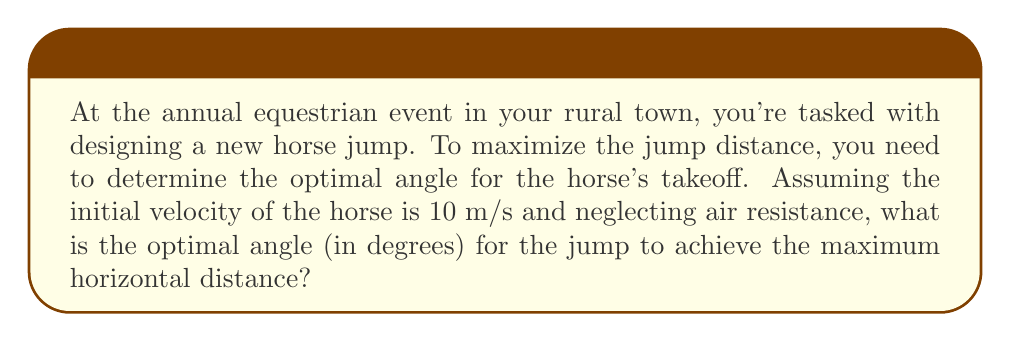What is the answer to this math problem? To solve this problem, we'll use the principles of projectile motion in calculus. The optimal angle for maximum distance in projectile motion is always 45°, but let's derive this mathematically:

1. The horizontal distance (d) traveled by a projectile is given by:
   $$d = v_0 \cos(\theta) \cdot t$$
   where $v_0$ is the initial velocity, $\theta$ is the launch angle, and $t$ is the time of flight.

2. The time of flight is determined by the vertical motion:
   $$t = \frac{2v_0 \sin(\theta)}{g}$$
   where $g$ is the acceleration due to gravity (9.8 m/s²).

3. Substituting the time into the distance equation:
   $$d = v_0 \cos(\theta) \cdot \frac{2v_0 \sin(\theta)}{g} = \frac{2v_0^2}{g} \sin(\theta)\cos(\theta)$$

4. Using the trigonometric identity $\sin(2\theta) = 2\sin(\theta)\cos(\theta)$, we get:
   $$d = \frac{v_0^2}{g} \sin(2\theta)$$

5. To find the maximum distance, we differentiate with respect to $\theta$ and set it to zero:
   $$\frac{dd}{d\theta} = \frac{v_0^2}{g} \cdot 2\cos(2\theta) = 0$$

6. Solving this equation:
   $$2\cos(2\theta) = 0$$
   $$\cos(2\theta) = 0$$
   $$2\theta = 90°$$
   $$\theta = 45°$$

Therefore, the optimal angle for maximum distance is 45°, regardless of the initial velocity.
Answer: 45° 